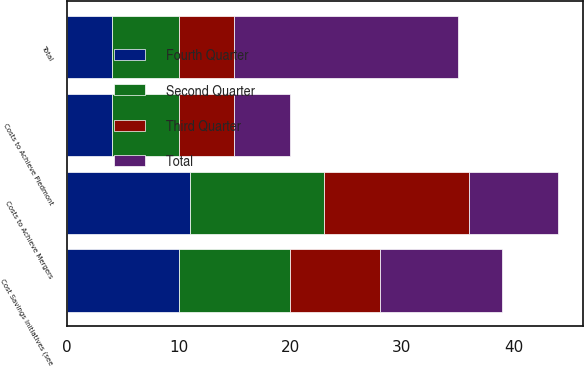Convert chart to OTSL. <chart><loc_0><loc_0><loc_500><loc_500><stacked_bar_chart><ecel><fcel>Costs to Achieve Piedmont<fcel>Total<fcel>Costs to Achieve Mergers<fcel>Cost Savings Initiatives (see<nl><fcel>Fourth Quarter<fcel>4<fcel>4<fcel>11<fcel>10<nl><fcel>Second Quarter<fcel>6<fcel>6<fcel>12<fcel>10<nl><fcel>Third Quarter<fcel>5<fcel>5<fcel>13<fcel>8<nl><fcel>Total<fcel>5<fcel>20<fcel>8<fcel>11<nl></chart> 